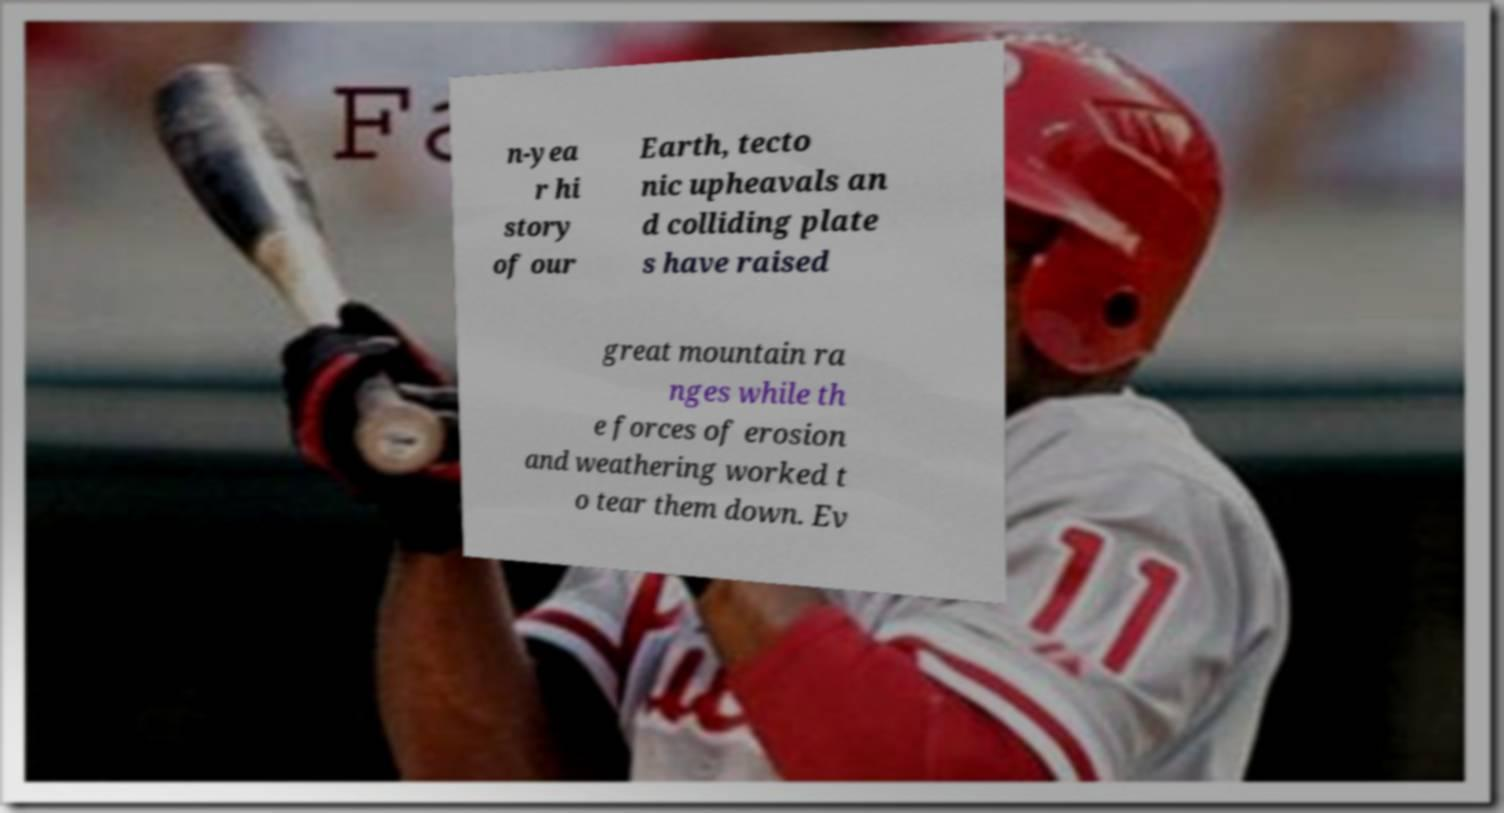For documentation purposes, I need the text within this image transcribed. Could you provide that? n-yea r hi story of our Earth, tecto nic upheavals an d colliding plate s have raised great mountain ra nges while th e forces of erosion and weathering worked t o tear them down. Ev 